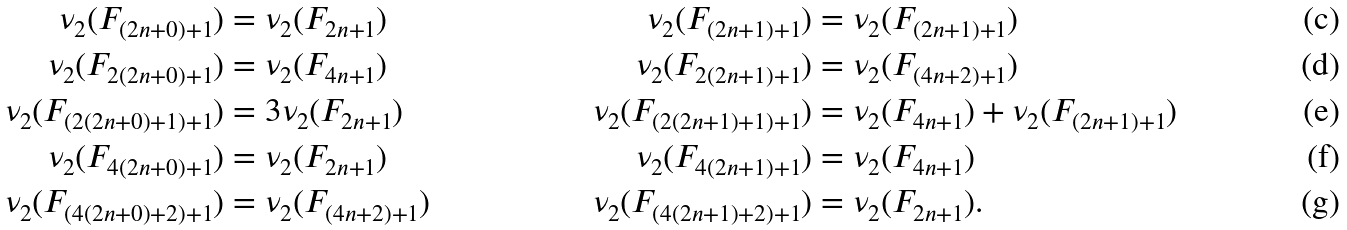Convert formula to latex. <formula><loc_0><loc_0><loc_500><loc_500>\nu _ { 2 } ( F _ { ( 2 n + 0 ) + 1 } ) & = \nu _ { 2 } ( F _ { 2 n + 1 } ) & \nu _ { 2 } ( F _ { ( 2 n + 1 ) + 1 } ) & = \nu _ { 2 } ( F _ { ( 2 n + 1 ) + 1 } ) \\ \nu _ { 2 } ( F _ { 2 ( 2 n + 0 ) + 1 } ) & = \nu _ { 2 } ( F _ { 4 n + 1 } ) & \nu _ { 2 } ( F _ { 2 ( 2 n + 1 ) + 1 } ) & = \nu _ { 2 } ( F _ { ( 4 n + 2 ) + 1 } ) \\ \nu _ { 2 } ( F _ { ( 2 ( 2 n + 0 ) + 1 ) + 1 } ) & = 3 \nu _ { 2 } ( F _ { 2 n + 1 } ) & \nu _ { 2 } ( F _ { ( 2 ( 2 n + 1 ) + 1 ) + 1 } ) & = \nu _ { 2 } ( F _ { 4 n + 1 } ) + \nu _ { 2 } ( F _ { ( 2 n + 1 ) + 1 } ) \\ \nu _ { 2 } ( F _ { 4 ( 2 n + 0 ) + 1 } ) & = \nu _ { 2 } ( F _ { 2 n + 1 } ) & \nu _ { 2 } ( F _ { 4 ( 2 n + 1 ) + 1 } ) & = \nu _ { 2 } ( F _ { 4 n + 1 } ) \\ \nu _ { 2 } ( F _ { ( 4 ( 2 n + 0 ) + 2 ) + 1 } ) & = \nu _ { 2 } ( F _ { ( 4 n + 2 ) + 1 } ) & \nu _ { 2 } ( F _ { ( 4 ( 2 n + 1 ) + 2 ) + 1 } ) & = \nu _ { 2 } ( F _ { 2 n + 1 } ) .</formula> 